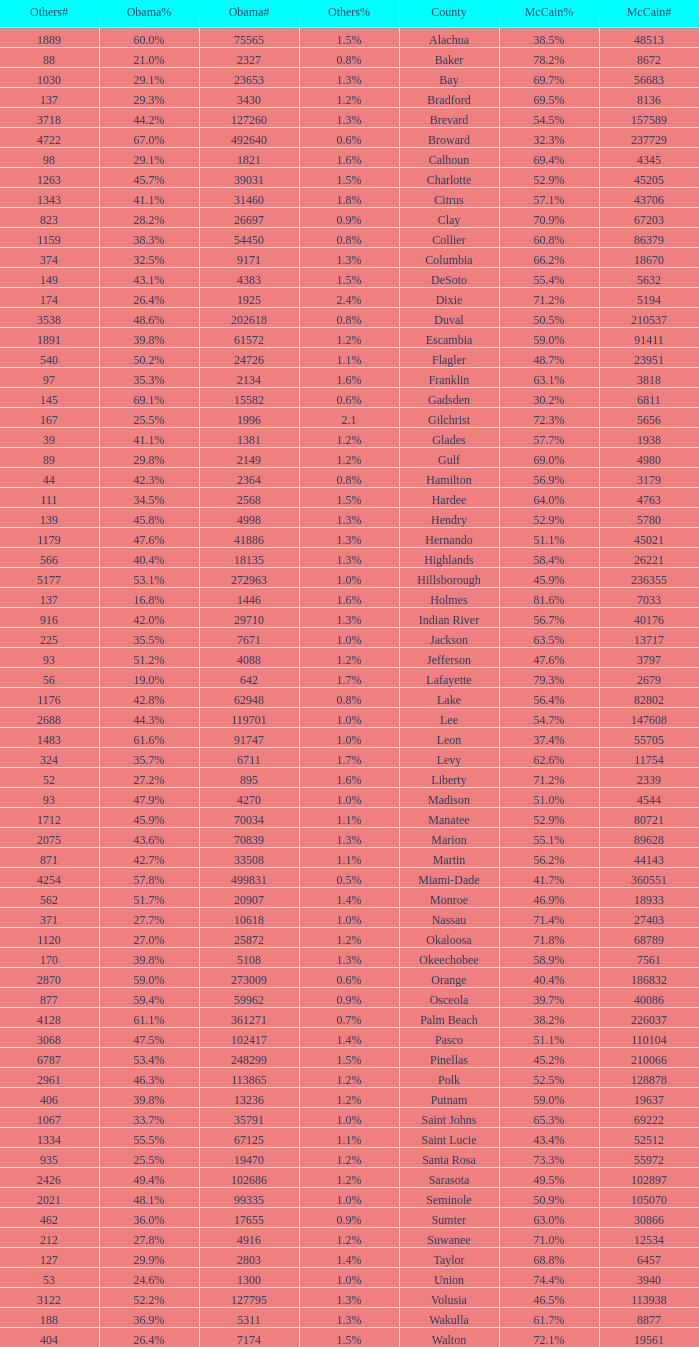What was the number of others votes in Columbia county? 374.0. 